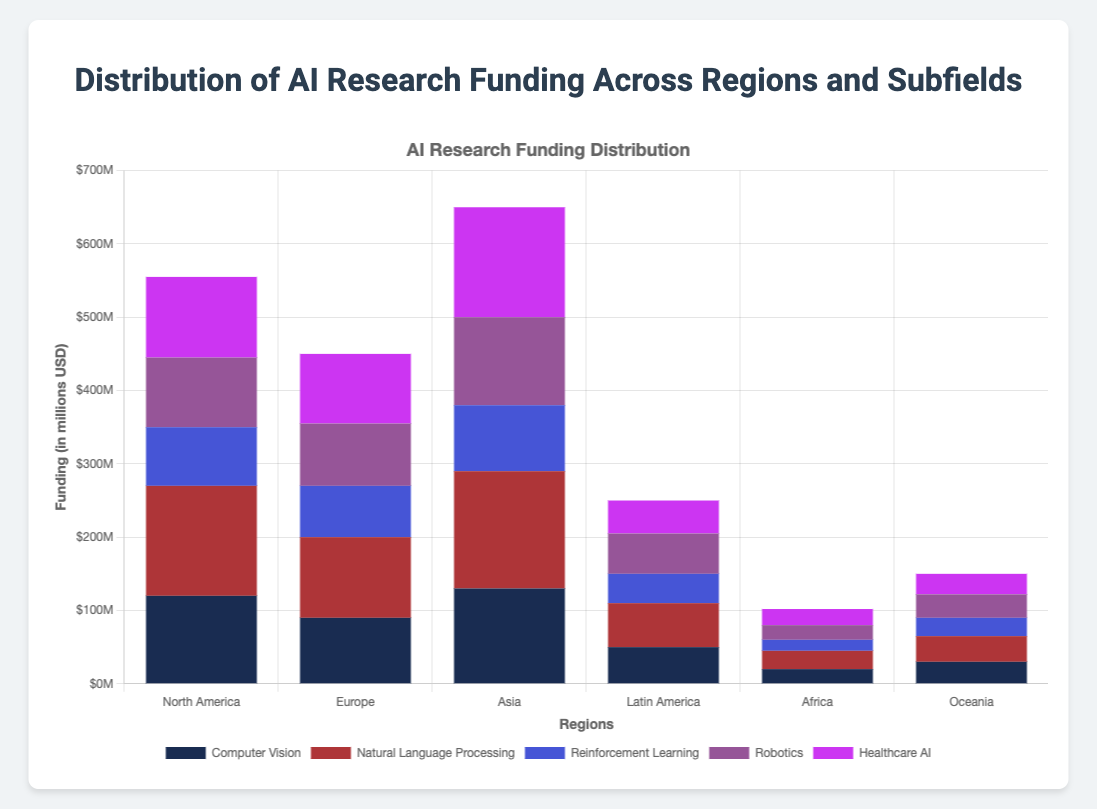Which region receives the highest total funding in AI research? To find the region with the highest total funding, sum the funding amounts for each subfield within each region, and compare the totals. North America: 120 + 150 + 80 + 95 + 110 = 555M; Europe: 90 + 110 + 70 + 85 + 95 = 450M; Asia: 130 + 160 + 90 + 120 + 150 = 650M; Latin America: 50 + 60 + 40 + 55 + 45 = 250M; Africa: 20 + 25 + 15 + 20 + 22 = 102M; Oceania: 30 + 35 + 25 + 32 + 28 = 150M; Asia has the highest total funding.
Answer: Asia Which AI subfield has the highest funding in North America? To determine the subfield with the highest funding in North America, look at the individual funding amounts in each subfield for the North America region. The values are: Computer Vision: 120M, Natural Language Processing: 150M, Reinforcement Learning: 80M, Robotics: 95M, Healthcare AI: 110M. Natural Language Processing has the highest funding.
Answer: Natural Language Processing Compare the total funding for Reinforcement Learning between Europe and Asia, which region funds it more? To compare the funding for Reinforcement Learning between Europe and Asia, look at the funding amounts. Europe has 70M, and Asia has 90M for Reinforcement Learning. Therefore, Asia funds it more.
Answer: Asia What is the difference in funding between the highest-funded and lowest-funded subfields in Latin America? First, find the highest-funded and lowest-funded subfields in Latin America. The values are: Computer Vision: 50M, Natural Language Processing: 60M, Reinforcement Learning: 40M, Robotics: 55M, Healthcare AI: 45M. Highest is Natural Language Processing with 60M, and lowest is Reinforcement Learning with 40M. The difference is 60M - 40M = 20M.
Answer: 20M What is the total funding for all regions in Healthcare AI? Sum the funding amounts for Healthcare AI across all regions: North America: 110M, Europe: 95M, Asia: 150M, Latin America: 45M, Africa: 22M, Oceania: 28M. The total is 110 + 95 + 150 + 45 + 22 + 28 = 450M.
Answer: 450M Which subfield has the most funding in Europe, and by how much does it exceed the second highest? In Europe, the funding amounts by subfield are: Computer Vision: 90M, Natural Language Processing: 110M, Reinforcement Learning: 70M, Robotics: 85M, Healthcare AI: 95M. The highest is Natural Language Processing with 110M, and the second highest is Healthcare AI with 95M. The difference is 110M - 95M = 15M.
Answer: Natural Language Processing, 15M What color represents Healthcare AI in the chart? Identify the color associated with the Healthcare AI subfield in the legend of the stacked bar chart.
Answer: (Assumed as an example since color is not predetermined) What is the average funding per subfield in North America? Sum the funding amounts for each subfield in North America and divide by the number of subfields. The total funding is 555M, and there are 5 subfields. The average funding is 555M / 5 = 111M.
Answer: 111M How much more funding does Asia provide for Robotics compared to Oceania? Look at the funding for Robotics in Asia and Oceania: Asia has 120M and Oceania has 32M. The difference is 120M - 32M = 88M.
Answer: 88M 